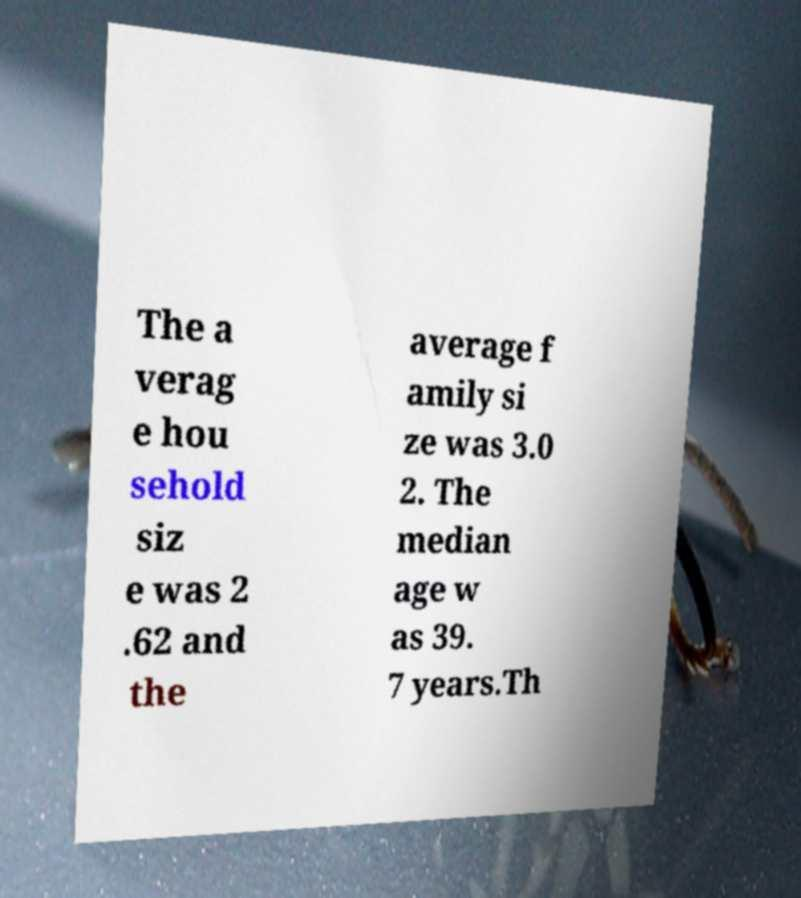Can you accurately transcribe the text from the provided image for me? The a verag e hou sehold siz e was 2 .62 and the average f amily si ze was 3.0 2. The median age w as 39. 7 years.Th 